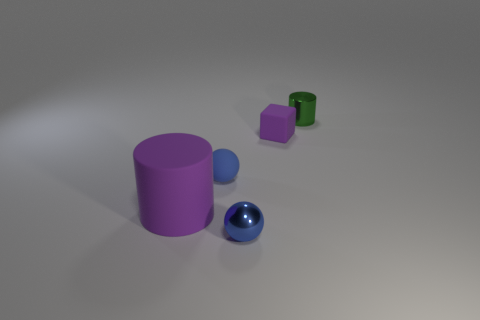There is a thing that is the same color as the rubber sphere; what size is it?
Ensure brevity in your answer.  Small. Do the matte thing in front of the blue matte object and the small metallic cylinder have the same size?
Your response must be concise. No. How many metallic things are both in front of the big cylinder and to the right of the tiny purple rubber block?
Offer a terse response. 0. What is the size of the purple object that is on the left side of the purple thing that is behind the big cylinder?
Ensure brevity in your answer.  Large. Is the number of purple blocks that are on the right side of the tiny block less than the number of tiny blue rubber things behind the big rubber object?
Ensure brevity in your answer.  Yes. There is a shiny object in front of the tiny purple matte block; is it the same color as the sphere on the left side of the blue metal object?
Give a very brief answer. Yes. What material is the object that is both to the right of the small blue rubber sphere and left of the tiny purple object?
Your response must be concise. Metal. Are there any blue metal cylinders?
Ensure brevity in your answer.  No. What is the shape of the purple object that is made of the same material as the big purple cylinder?
Your answer should be very brief. Cube. Do the green shiny object and the metal thing in front of the green cylinder have the same shape?
Provide a short and direct response. No. 